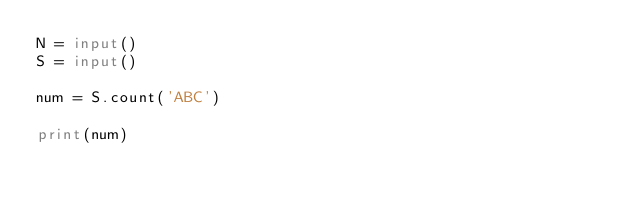Convert code to text. <code><loc_0><loc_0><loc_500><loc_500><_Python_>N = input()
S = input()

num = S.count('ABC')

print(num)</code> 